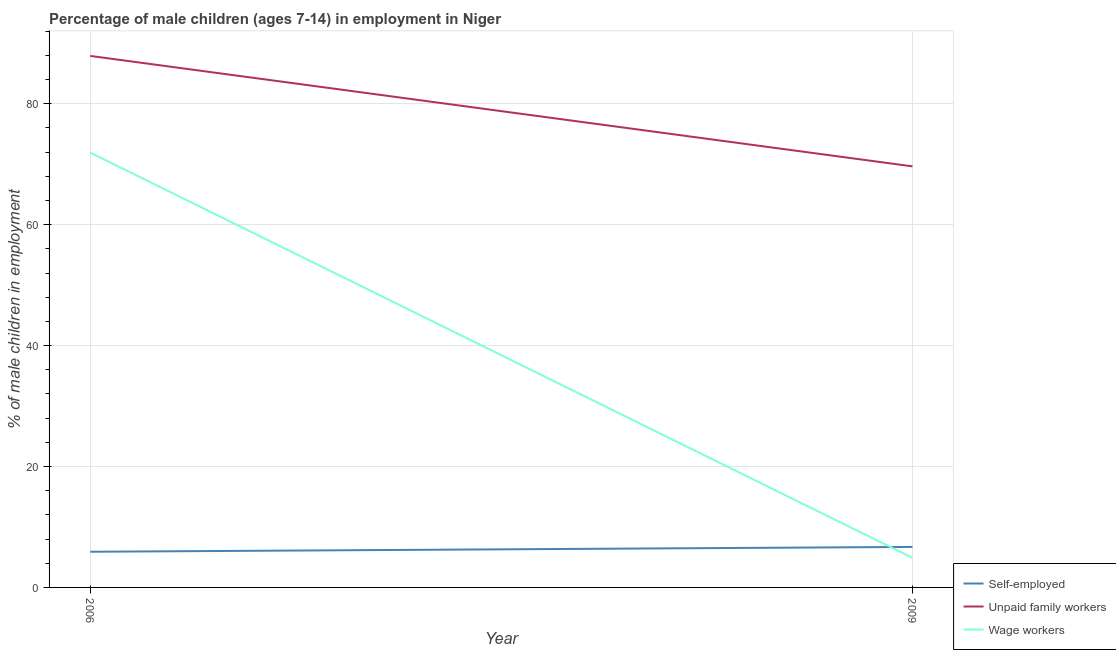How many different coloured lines are there?
Keep it short and to the point. 3. Is the number of lines equal to the number of legend labels?
Ensure brevity in your answer.  Yes. What is the percentage of children employed as unpaid family workers in 2006?
Your answer should be compact. 87.92. Across all years, what is the maximum percentage of self employed children?
Offer a terse response. 6.7. Across all years, what is the minimum percentage of children employed as wage workers?
Your answer should be very brief. 4.89. What is the total percentage of self employed children in the graph?
Offer a very short reply. 12.6. What is the difference between the percentage of children employed as wage workers in 2006 and that in 2009?
Keep it short and to the point. 67.04. What is the difference between the percentage of children employed as wage workers in 2006 and the percentage of self employed children in 2009?
Make the answer very short. 65.23. What is the average percentage of children employed as wage workers per year?
Your answer should be very brief. 38.41. In the year 2009, what is the difference between the percentage of children employed as unpaid family workers and percentage of self employed children?
Your answer should be very brief. 62.95. What is the ratio of the percentage of children employed as unpaid family workers in 2006 to that in 2009?
Make the answer very short. 1.26. Does the percentage of children employed as unpaid family workers monotonically increase over the years?
Give a very brief answer. No. Is the percentage of children employed as wage workers strictly greater than the percentage of self employed children over the years?
Provide a succinct answer. No. Is the percentage of self employed children strictly less than the percentage of children employed as wage workers over the years?
Make the answer very short. No. How many lines are there?
Your answer should be compact. 3. How many years are there in the graph?
Provide a succinct answer. 2. Are the values on the major ticks of Y-axis written in scientific E-notation?
Keep it short and to the point. No. How many legend labels are there?
Give a very brief answer. 3. What is the title of the graph?
Your answer should be very brief. Percentage of male children (ages 7-14) in employment in Niger. Does "Secondary" appear as one of the legend labels in the graph?
Your answer should be compact. No. What is the label or title of the Y-axis?
Offer a terse response. % of male children in employment. What is the % of male children in employment in Unpaid family workers in 2006?
Your response must be concise. 87.92. What is the % of male children in employment of Wage workers in 2006?
Offer a terse response. 71.93. What is the % of male children in employment in Self-employed in 2009?
Give a very brief answer. 6.7. What is the % of male children in employment of Unpaid family workers in 2009?
Make the answer very short. 69.65. What is the % of male children in employment in Wage workers in 2009?
Ensure brevity in your answer.  4.89. Across all years, what is the maximum % of male children in employment in Unpaid family workers?
Ensure brevity in your answer.  87.92. Across all years, what is the maximum % of male children in employment of Wage workers?
Offer a very short reply. 71.93. Across all years, what is the minimum % of male children in employment of Unpaid family workers?
Ensure brevity in your answer.  69.65. Across all years, what is the minimum % of male children in employment in Wage workers?
Offer a very short reply. 4.89. What is the total % of male children in employment of Unpaid family workers in the graph?
Offer a very short reply. 157.57. What is the total % of male children in employment of Wage workers in the graph?
Provide a short and direct response. 76.82. What is the difference between the % of male children in employment of Self-employed in 2006 and that in 2009?
Make the answer very short. -0.8. What is the difference between the % of male children in employment in Unpaid family workers in 2006 and that in 2009?
Your response must be concise. 18.27. What is the difference between the % of male children in employment in Wage workers in 2006 and that in 2009?
Provide a short and direct response. 67.04. What is the difference between the % of male children in employment of Self-employed in 2006 and the % of male children in employment of Unpaid family workers in 2009?
Your answer should be very brief. -63.75. What is the difference between the % of male children in employment in Self-employed in 2006 and the % of male children in employment in Wage workers in 2009?
Offer a terse response. 1.01. What is the difference between the % of male children in employment in Unpaid family workers in 2006 and the % of male children in employment in Wage workers in 2009?
Give a very brief answer. 83.03. What is the average % of male children in employment of Self-employed per year?
Offer a very short reply. 6.3. What is the average % of male children in employment in Unpaid family workers per year?
Ensure brevity in your answer.  78.78. What is the average % of male children in employment of Wage workers per year?
Your answer should be compact. 38.41. In the year 2006, what is the difference between the % of male children in employment in Self-employed and % of male children in employment in Unpaid family workers?
Make the answer very short. -82.02. In the year 2006, what is the difference between the % of male children in employment in Self-employed and % of male children in employment in Wage workers?
Ensure brevity in your answer.  -66.03. In the year 2006, what is the difference between the % of male children in employment of Unpaid family workers and % of male children in employment of Wage workers?
Your answer should be very brief. 15.99. In the year 2009, what is the difference between the % of male children in employment in Self-employed and % of male children in employment in Unpaid family workers?
Keep it short and to the point. -62.95. In the year 2009, what is the difference between the % of male children in employment of Self-employed and % of male children in employment of Wage workers?
Your answer should be very brief. 1.81. In the year 2009, what is the difference between the % of male children in employment in Unpaid family workers and % of male children in employment in Wage workers?
Offer a very short reply. 64.76. What is the ratio of the % of male children in employment in Self-employed in 2006 to that in 2009?
Your answer should be very brief. 0.88. What is the ratio of the % of male children in employment of Unpaid family workers in 2006 to that in 2009?
Provide a short and direct response. 1.26. What is the ratio of the % of male children in employment of Wage workers in 2006 to that in 2009?
Offer a very short reply. 14.71. What is the difference between the highest and the second highest % of male children in employment in Self-employed?
Offer a very short reply. 0.8. What is the difference between the highest and the second highest % of male children in employment of Unpaid family workers?
Offer a terse response. 18.27. What is the difference between the highest and the second highest % of male children in employment of Wage workers?
Offer a terse response. 67.04. What is the difference between the highest and the lowest % of male children in employment of Unpaid family workers?
Your response must be concise. 18.27. What is the difference between the highest and the lowest % of male children in employment in Wage workers?
Give a very brief answer. 67.04. 